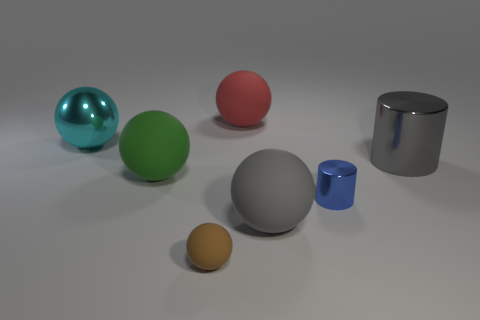Add 1 small blue rubber blocks. How many objects exist? 8 Subtract all large red spheres. How many spheres are left? 4 Subtract all gray spheres. How many spheres are left? 4 Subtract 3 balls. How many balls are left? 2 Subtract all cyan metallic things. Subtract all small blue metal objects. How many objects are left? 5 Add 3 large cyan objects. How many large cyan objects are left? 4 Add 5 gray shiny objects. How many gray shiny objects exist? 6 Subtract 0 yellow blocks. How many objects are left? 7 Subtract all cylinders. How many objects are left? 5 Subtract all brown balls. Subtract all cyan cubes. How many balls are left? 4 